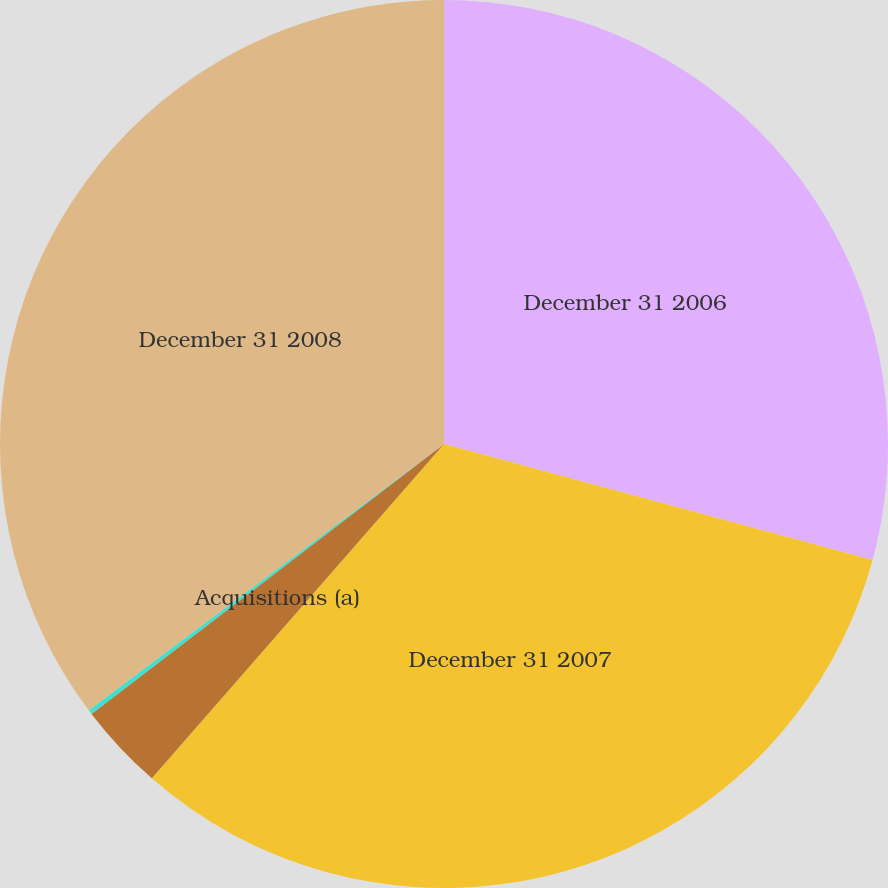Convert chart. <chart><loc_0><loc_0><loc_500><loc_500><pie_chart><fcel>December 31 2006<fcel>December 31 2007<fcel>Acquisitions (a)<fcel>Other (b)<fcel>December 31 2008<nl><fcel>29.21%<fcel>32.22%<fcel>3.17%<fcel>0.16%<fcel>35.24%<nl></chart> 